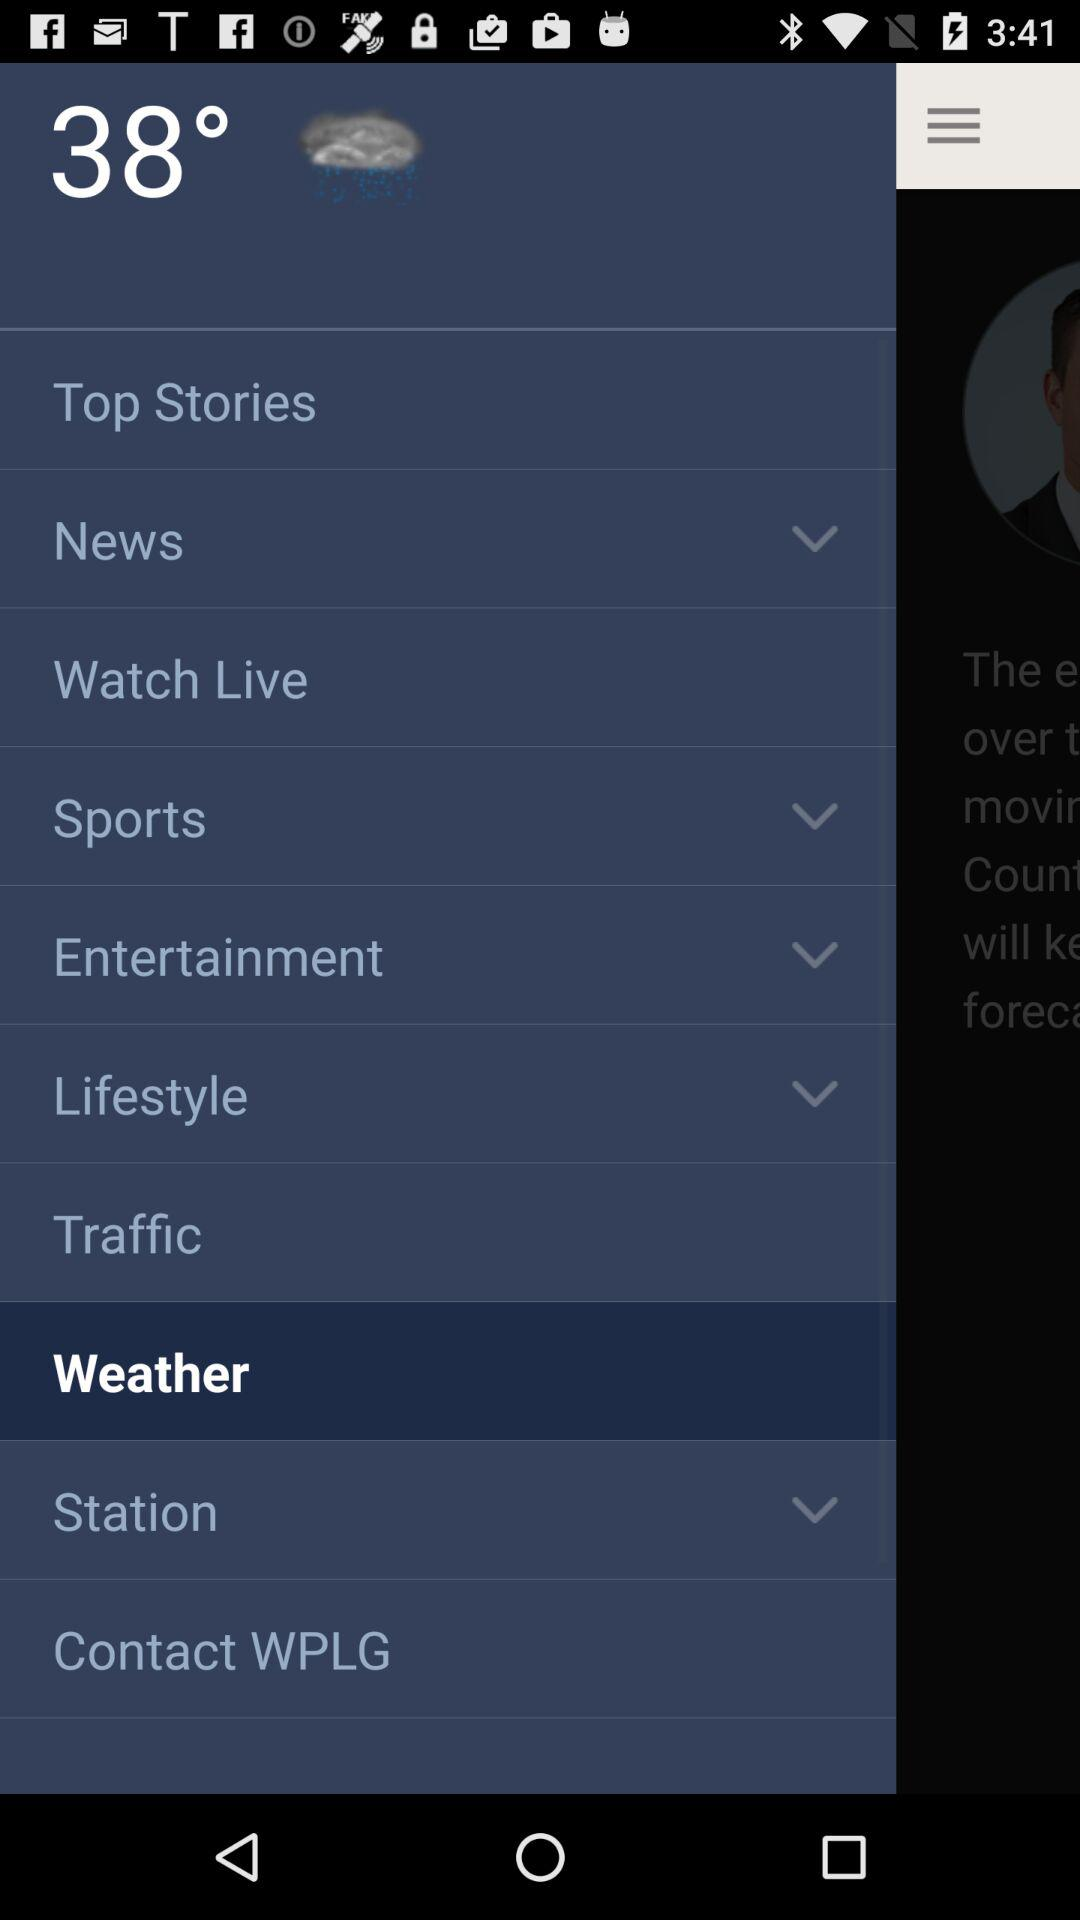What option has been selected? The selected option is "Weather". 